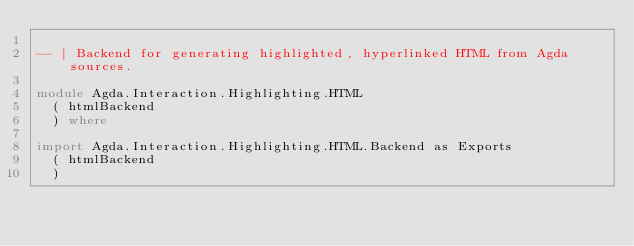Convert code to text. <code><loc_0><loc_0><loc_500><loc_500><_Haskell_>
-- | Backend for generating highlighted, hyperlinked HTML from Agda sources.

module Agda.Interaction.Highlighting.HTML
  ( htmlBackend
  ) where

import Agda.Interaction.Highlighting.HTML.Backend as Exports
  ( htmlBackend
  )
</code> 